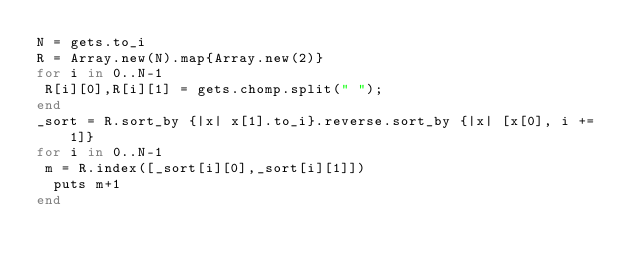<code> <loc_0><loc_0><loc_500><loc_500><_Ruby_>N = gets.to_i
R = Array.new(N).map{Array.new(2)}
for i in 0..N-1
 R[i][0],R[i][1] = gets.chomp.split(" ");
end
_sort = R.sort_by {|x| x[1].to_i}.reverse.sort_by {|x| [x[0], i += 1]}
for i in 0..N-1
 m = R.index([_sort[i][0],_sort[i][1]])
  puts m+1
end</code> 